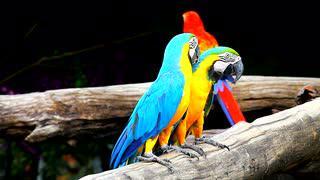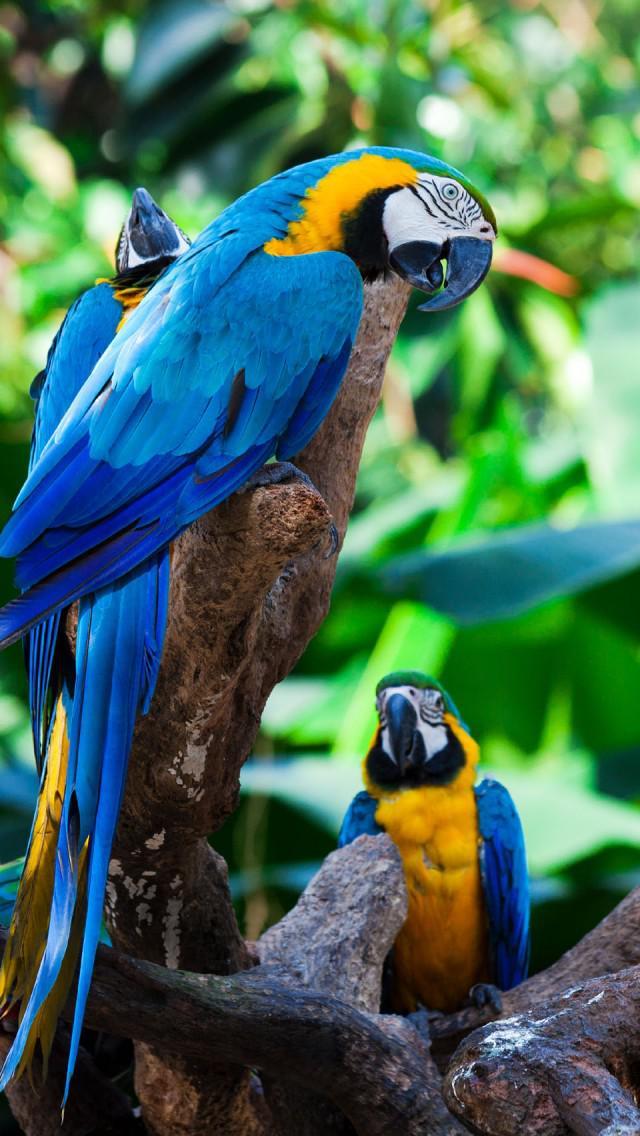The first image is the image on the left, the second image is the image on the right. For the images displayed, is the sentence "The image to the right is a row of yellow fronted macaws with one red one at the left end." factually correct? Answer yes or no. No. 